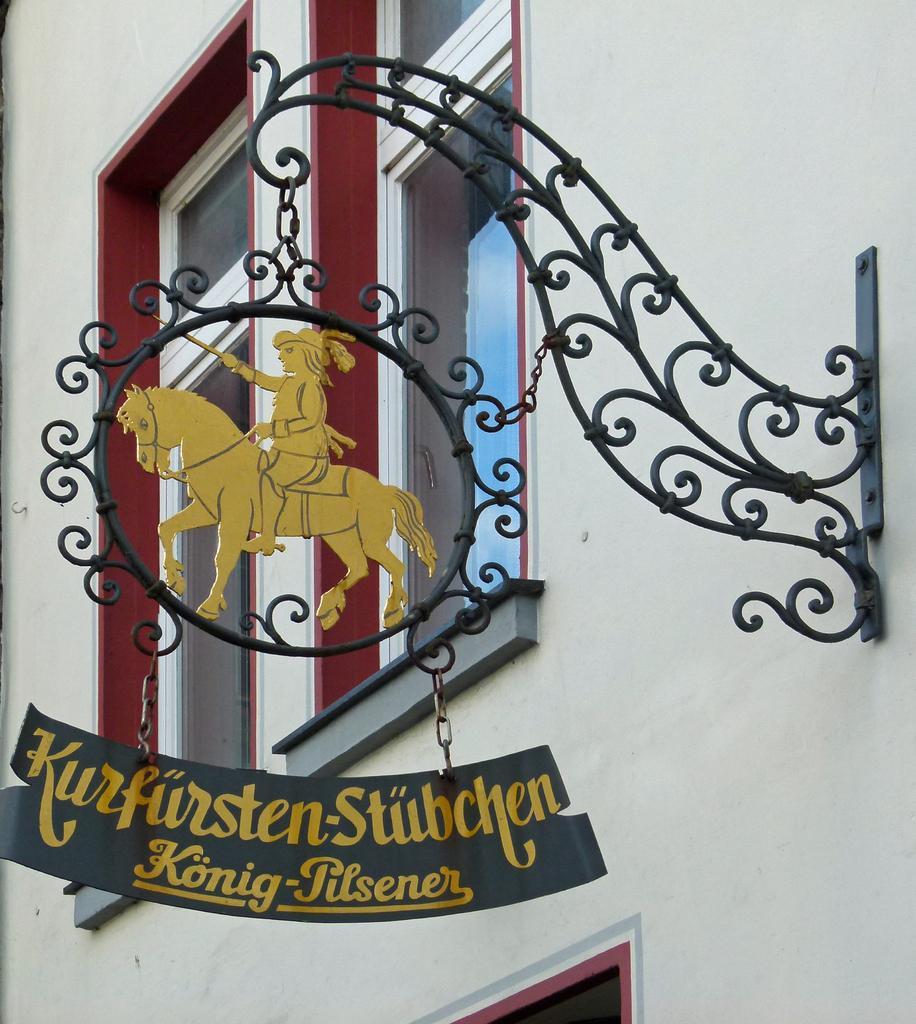Describe this image in one or two sentences. In this image there is a name board hanging to the iron grill, which is attached to the building. 